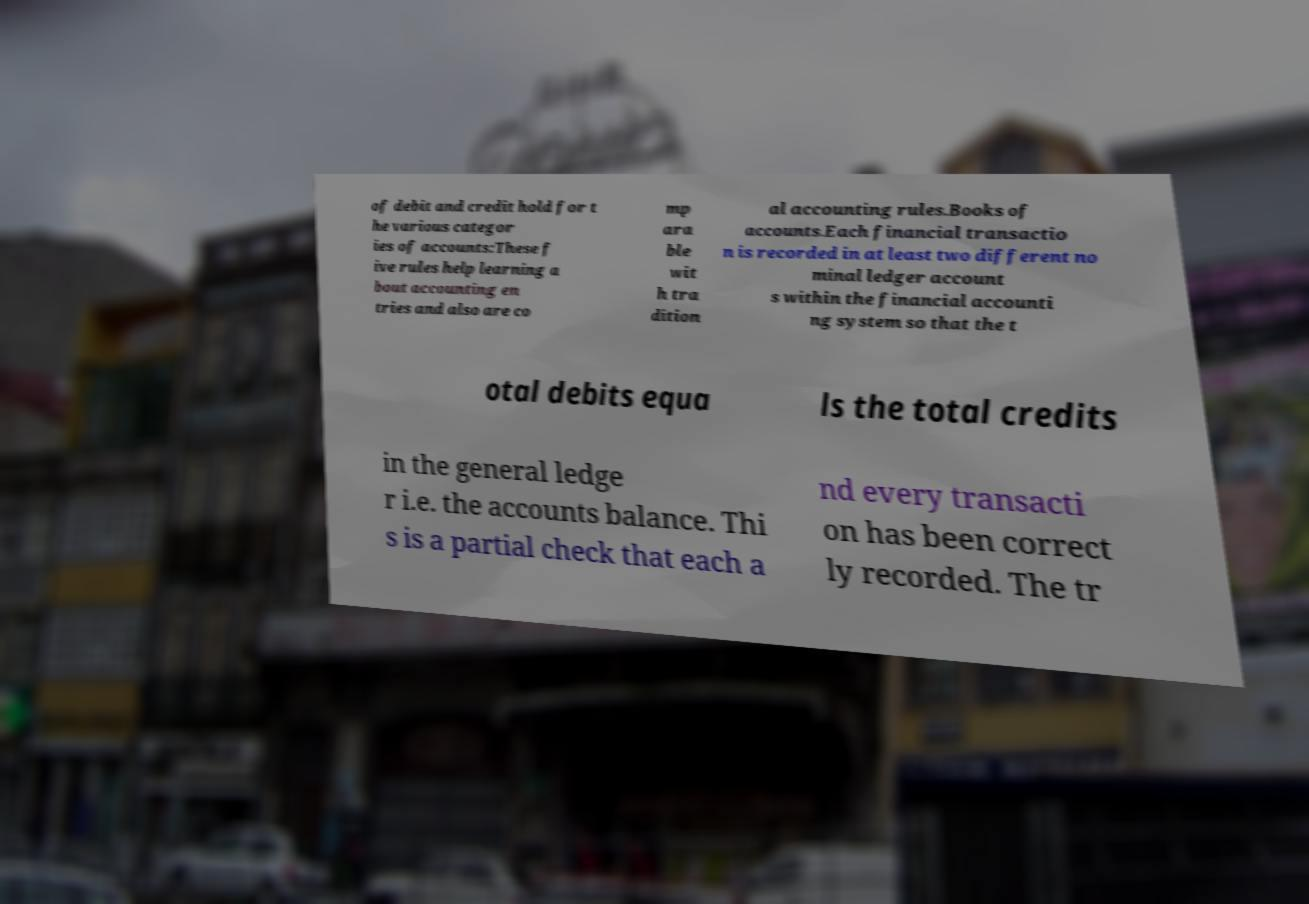There's text embedded in this image that I need extracted. Can you transcribe it verbatim? of debit and credit hold for t he various categor ies of accounts:These f ive rules help learning a bout accounting en tries and also are co mp ara ble wit h tra dition al accounting rules.Books of accounts.Each financial transactio n is recorded in at least two different no minal ledger account s within the financial accounti ng system so that the t otal debits equa ls the total credits in the general ledge r i.e. the accounts balance. Thi s is a partial check that each a nd every transacti on has been correct ly recorded. The tr 